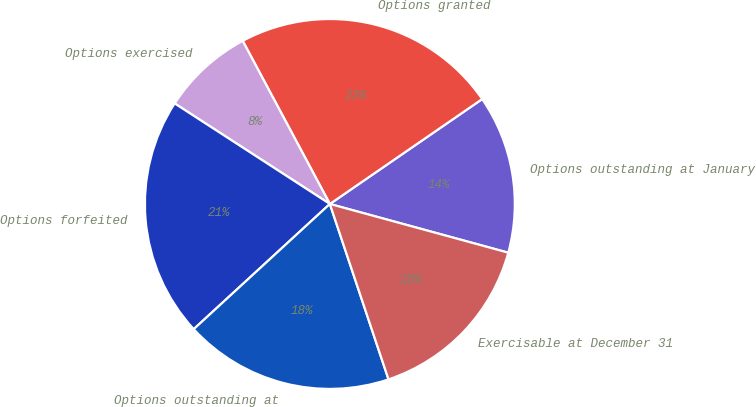Convert chart to OTSL. <chart><loc_0><loc_0><loc_500><loc_500><pie_chart><fcel>Options outstanding at January<fcel>Options granted<fcel>Options exercised<fcel>Options forfeited<fcel>Options outstanding at<fcel>Exercisable at December 31<nl><fcel>13.84%<fcel>23.21%<fcel>8.04%<fcel>20.98%<fcel>18.3%<fcel>15.62%<nl></chart> 